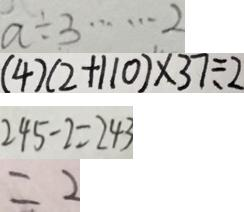Convert formula to latex. <formula><loc_0><loc_0><loc_500><loc_500>a \div 3 \cdots 2 
 ( 4 ) ( 2 + 1 1 0 ) \times 3 7 \div 2 
 2 4 5 - 2 = 2 4 3 
 = 2</formula> 